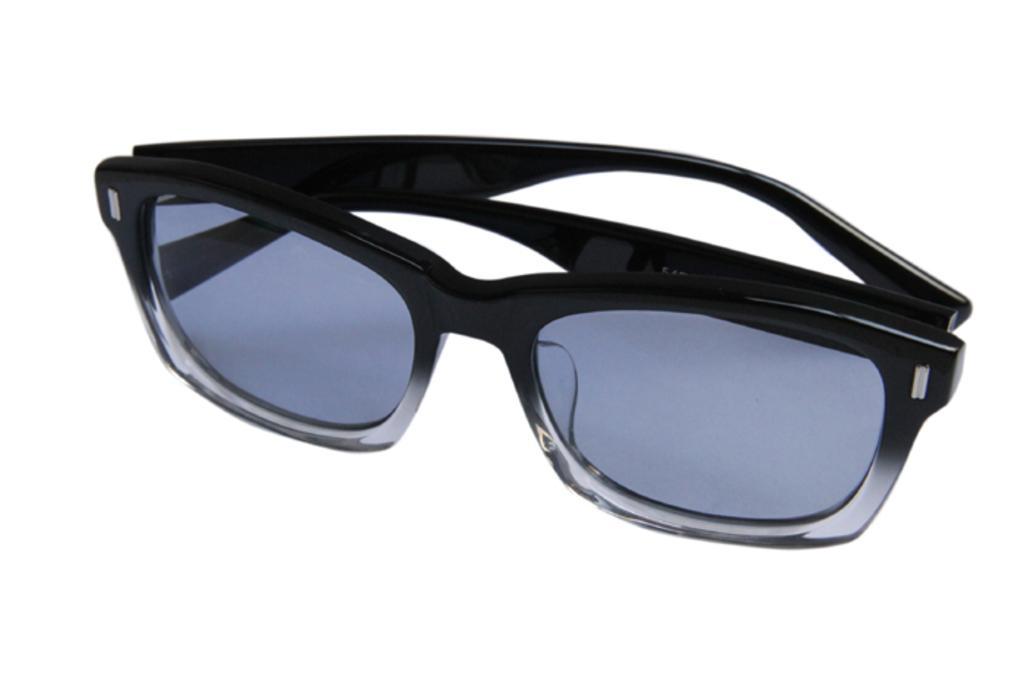Could you give a brief overview of what you see in this image? In the center of the image we can see sunglasses, which is in black color. 